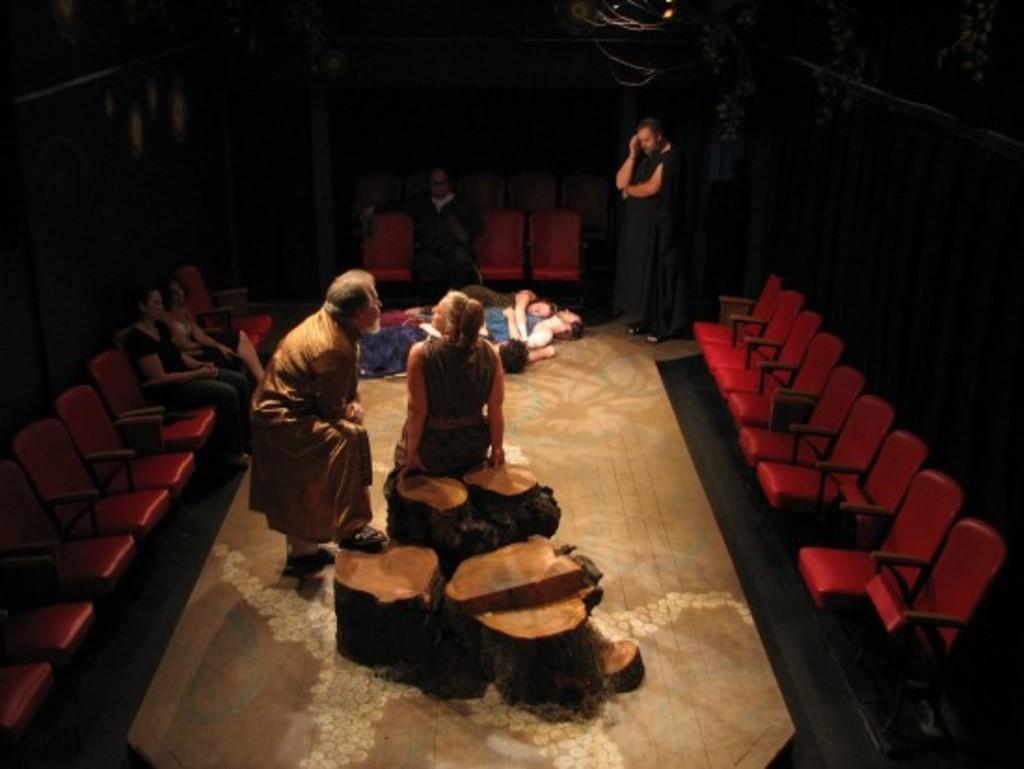Describe this image in one or two sentences. In the image we can see there are people standing on the chair and few people sitting on the chair and others are lying on the floor. 